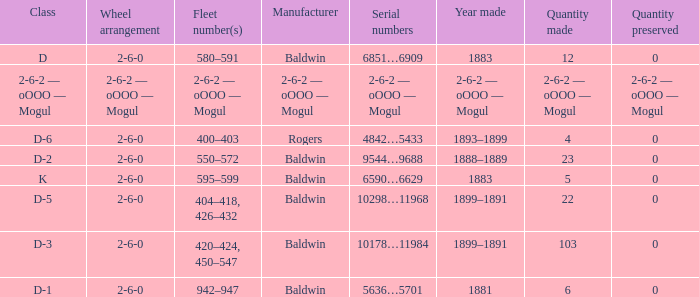What is the year made when the manufacturer is 2-6-2 — oooo — mogul? 2-6-2 — oOOO — Mogul. 